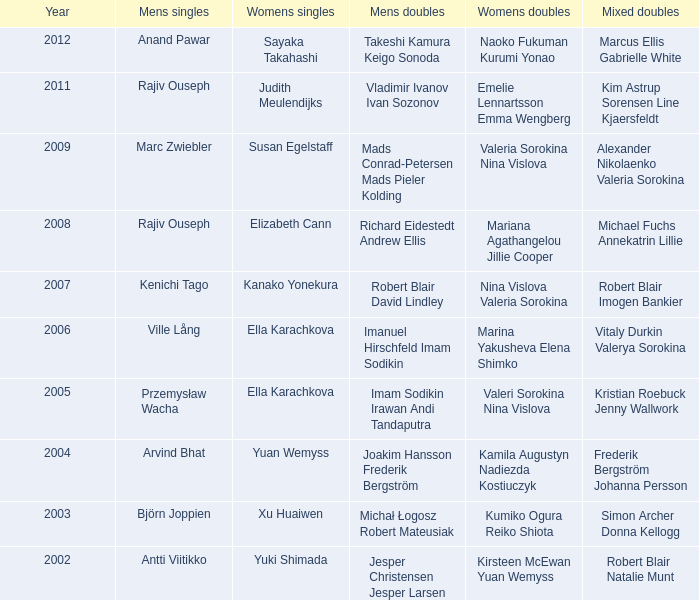What is the womens singles of marcus ellis gabrielle white? Sayaka Takahashi. 